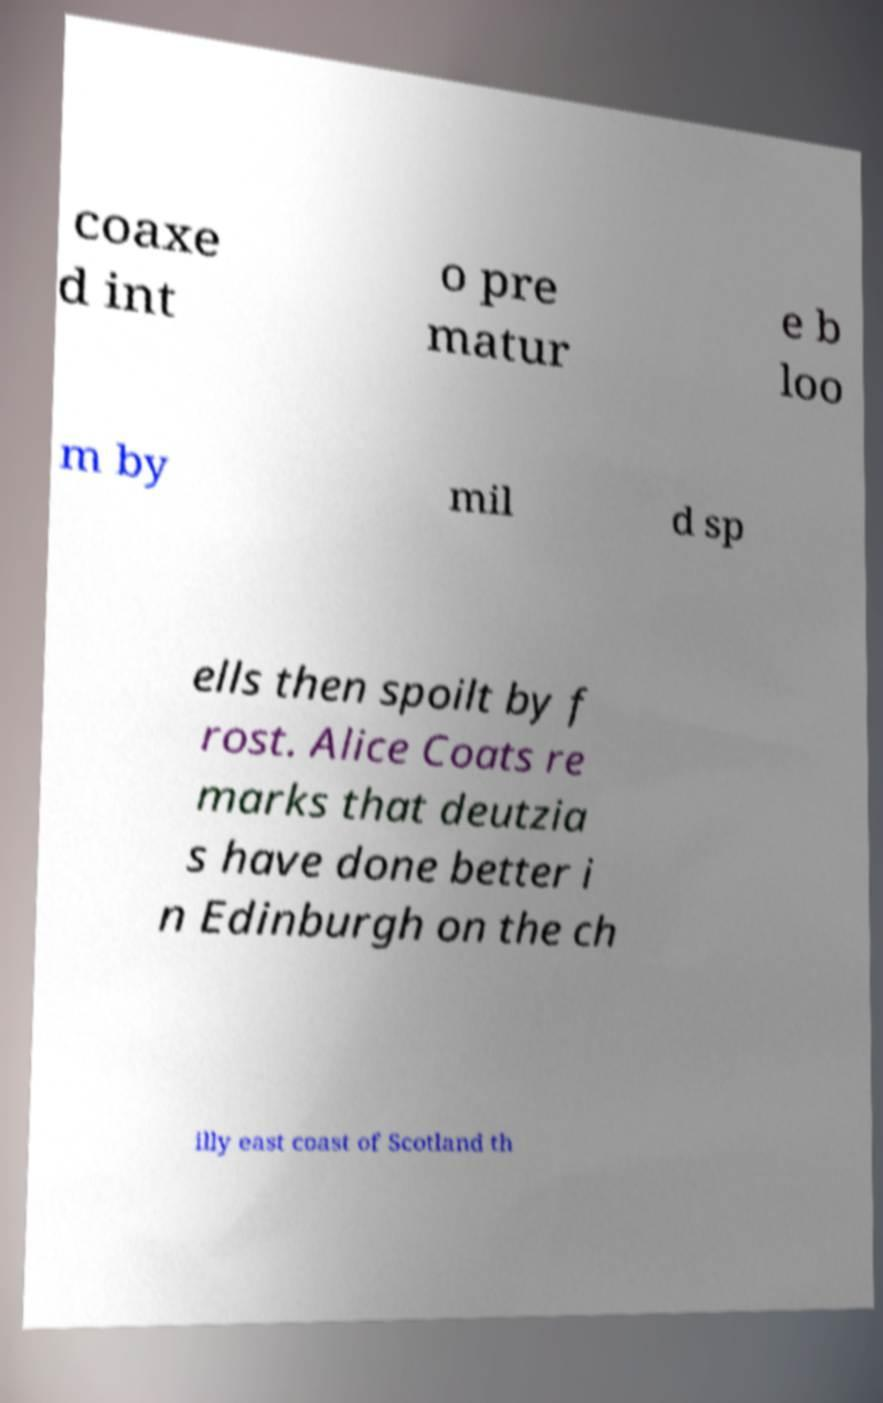I need the written content from this picture converted into text. Can you do that? coaxe d int o pre matur e b loo m by mil d sp ells then spoilt by f rost. Alice Coats re marks that deutzia s have done better i n Edinburgh on the ch illy east coast of Scotland th 